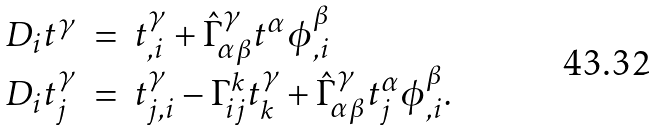Convert formula to latex. <formula><loc_0><loc_0><loc_500><loc_500>\begin{array} { r c l } D _ { i } t ^ { \gamma } & = & t ^ { \gamma } _ { , i } + \hat { \Gamma } ^ { \gamma } _ { \alpha \beta } t ^ { \alpha } \phi ^ { \beta } _ { , i } \\ D _ { i } t ^ { \gamma } _ { j } & = & t ^ { \gamma } _ { j , i } - \Gamma ^ { k } _ { i j } t ^ { \gamma } _ { k } + \hat { \Gamma } ^ { \gamma } _ { \alpha \beta } t ^ { \alpha } _ { j } \phi ^ { \beta } _ { , i } . \end{array}</formula> 